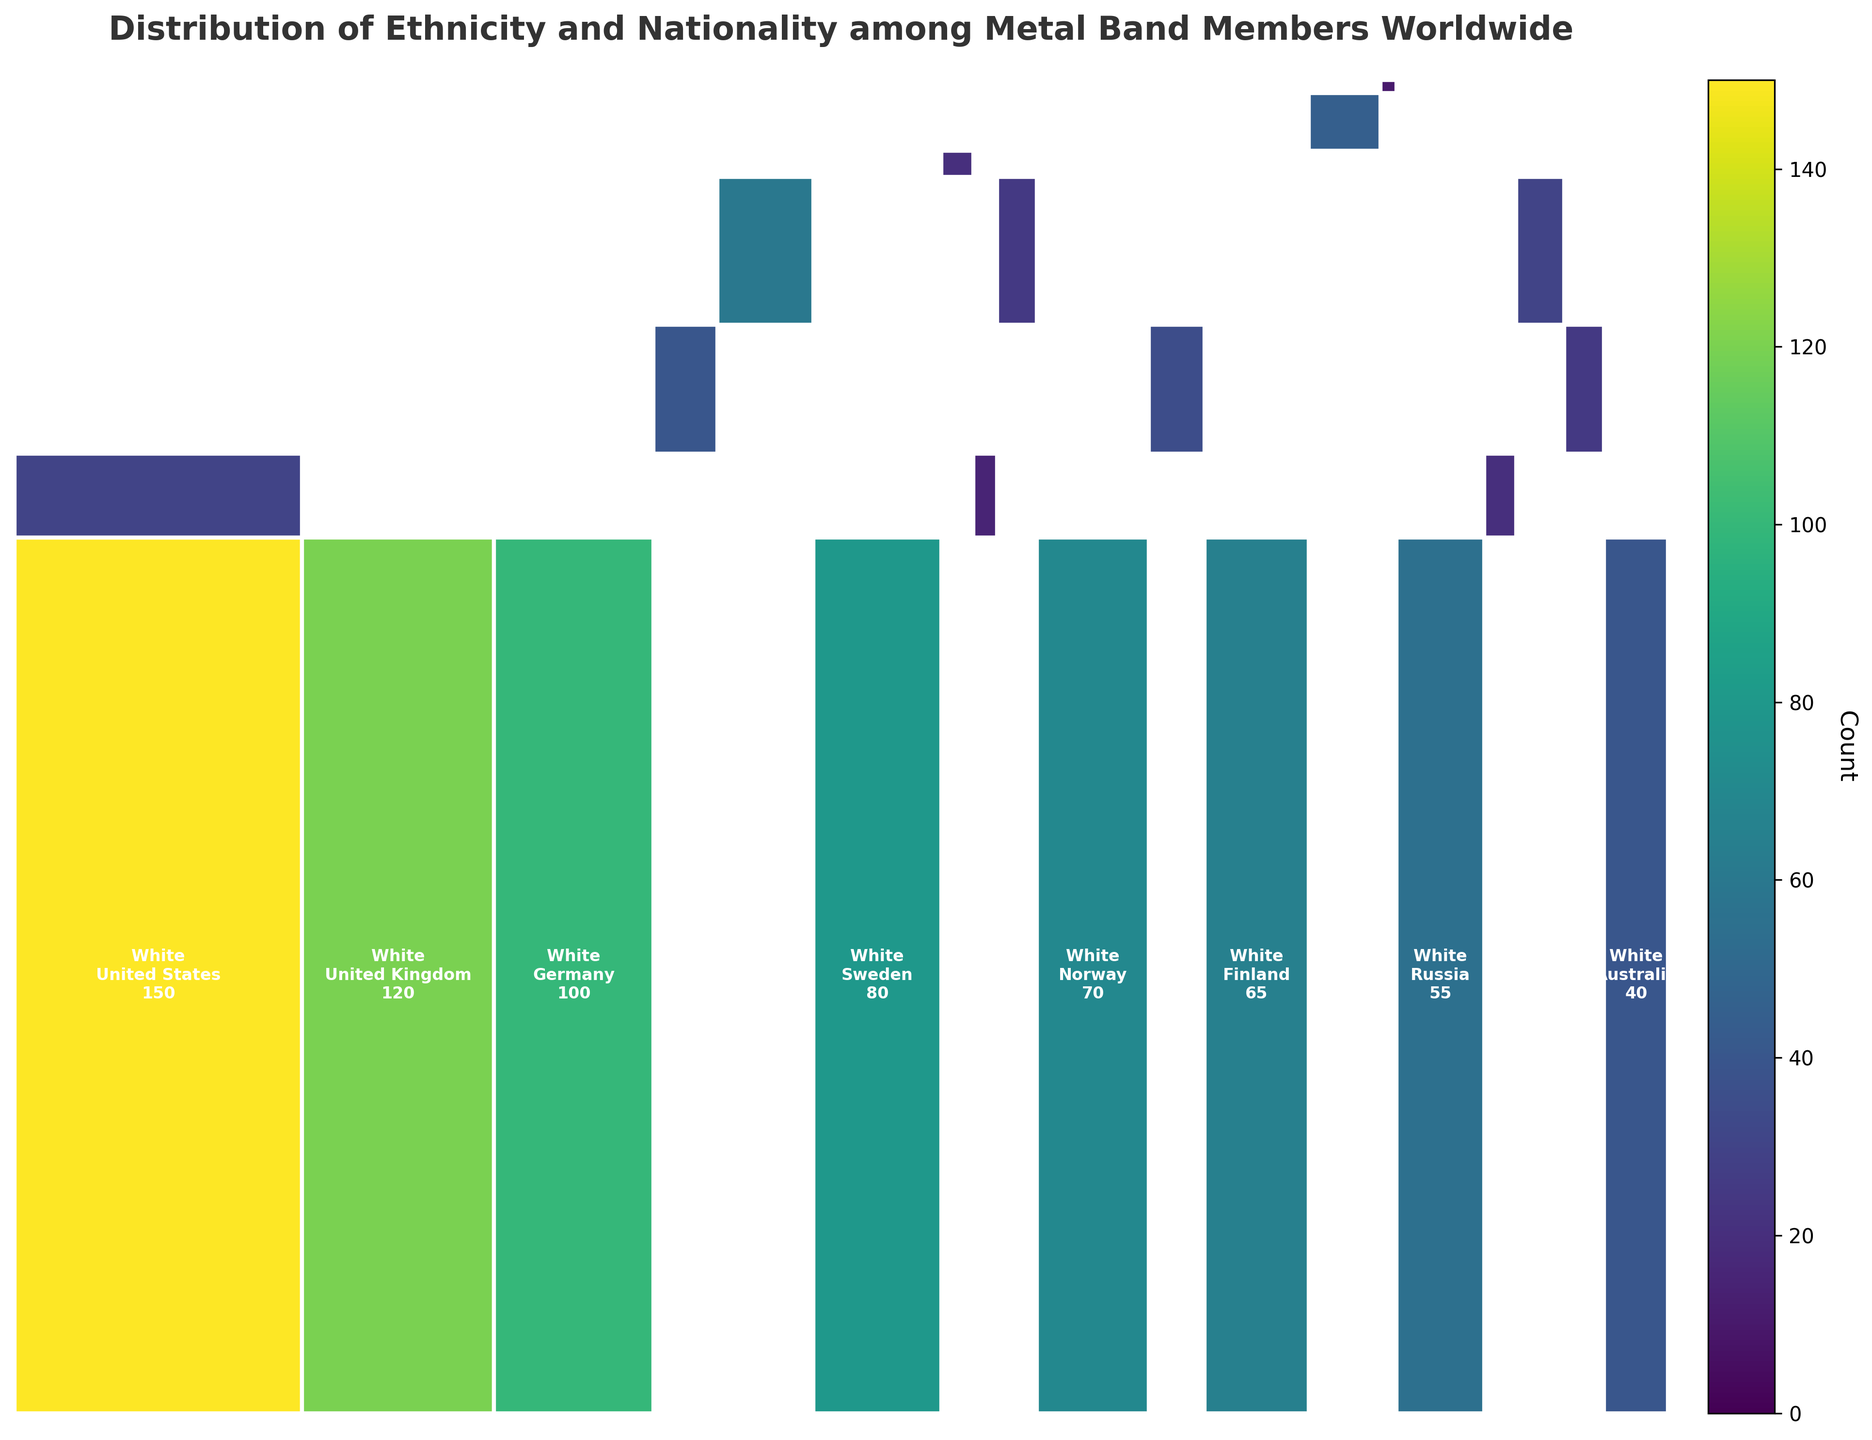What's the title of the mosaic plot? The title is the text displayed at the top of the figure, which summarizes the content depicted. From the description, the title is named "Distribution of Ethnicity and Nationality among Metal Band Members Worldwide".
Answer: Distribution of Ethnicity and Nationality among Metal Band Members Worldwide Which ethnicity has the highest count overall? To find the ethnicity with the highest count, observe the relative proportions of each ethnicity in the mosaic plot. The ethnicity occupying the largest vertical space corresponds to having the highest count of members. In this case, White has the highest overall count.
Answer: White Which nationality has the smallest count of metal band members? To determine the nationality with the smallest count, look for the rectangle representing the smallest horizontal portion of the mosaic plot. New Zealand, being the smallest in horizontal width, has the smallest count.
Answer: New Zealand What's the total count of White members from Germany and Sweden combined? Identify the counts for White members in Germany and Sweden from their respective rectangles in the mosaic plot. Germany has 100, and Sweden has 80. Sum these counts to get the combined total: 100 + 80 = 180.
Answer: 180 Which ethnicities are present in the United States? To find this, look for different ethnicities associated with the United States rectangle in the mosaic plot. The identified ethnicities are White and Black.
Answer: White, Black Which country has the highest number of Black metal band members? Observe the rectangles representing Black metal band members, noting the countries. Compare the areas to identify the largest. The United States has the highest count of Black metal band members.
Answer: United States How does the count of Asian members in Japan compare with those in China? Examine the mosaic plot for the counts in the Asian category for Japan and China. Japan has 60, and China has 25. Comparing the two values: 60 is greater than 25.
Answer: Japan has more members than China What's the total number of metal band members represented in the plot? Sum the counts for all entries provided in the data. The sum of counts is 150 + 120 + 100 + 30 + 40 + 60 + 80 + 20 + 15 + 25 + 70 + 35 + 65 + 45 + 10 + 55 + 20 + 30 + 25 + 40 = 1035.
Answer: 1035 Compare the number of Hispanic members in Brazil and Mexico. Look at the mosaic plot for the counts of Hispanic members in Brazil and Mexico. Brazil has 40, and Mexico has 35. Compare the two values: 40 is greater than 35.
Answer: Brazil has more Hispanic members than Mexico 